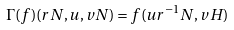<formula> <loc_0><loc_0><loc_500><loc_500>\Gamma ( f ) ( r N , u , v N ) = f ( u r ^ { - 1 } N , v H )</formula> 